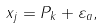<formula> <loc_0><loc_0><loc_500><loc_500>x _ { j } = P _ { k } + \varepsilon _ { a } ,</formula> 